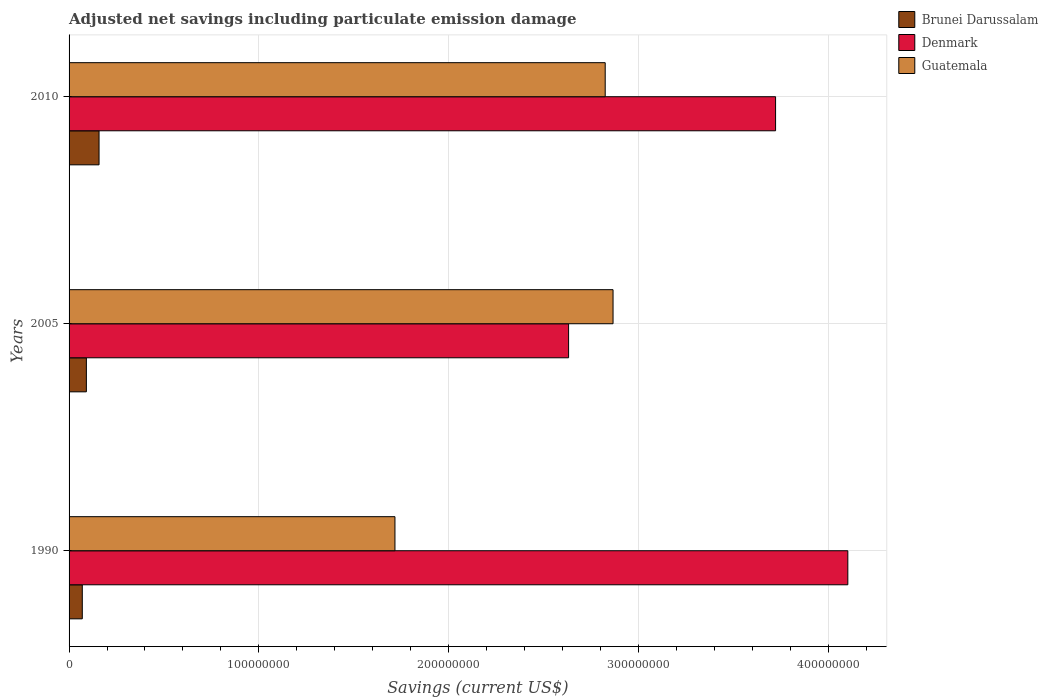How many different coloured bars are there?
Offer a very short reply. 3. How many groups of bars are there?
Keep it short and to the point. 3. How many bars are there on the 1st tick from the top?
Keep it short and to the point. 3. What is the net savings in Denmark in 2010?
Offer a terse response. 3.72e+08. Across all years, what is the maximum net savings in Guatemala?
Your answer should be compact. 2.87e+08. Across all years, what is the minimum net savings in Brunei Darussalam?
Ensure brevity in your answer.  6.97e+06. What is the total net savings in Brunei Darussalam in the graph?
Make the answer very short. 3.19e+07. What is the difference between the net savings in Guatemala in 2005 and that in 2010?
Your answer should be compact. 4.13e+06. What is the difference between the net savings in Guatemala in 2010 and the net savings in Brunei Darussalam in 2005?
Your answer should be compact. 2.73e+08. What is the average net savings in Denmark per year?
Give a very brief answer. 3.49e+08. In the year 2010, what is the difference between the net savings in Brunei Darussalam and net savings in Guatemala?
Your answer should be compact. -2.67e+08. What is the ratio of the net savings in Denmark in 1990 to that in 2010?
Keep it short and to the point. 1.1. What is the difference between the highest and the second highest net savings in Brunei Darussalam?
Your response must be concise. 6.68e+06. What is the difference between the highest and the lowest net savings in Guatemala?
Your answer should be compact. 1.15e+08. In how many years, is the net savings in Brunei Darussalam greater than the average net savings in Brunei Darussalam taken over all years?
Provide a succinct answer. 1. Is the sum of the net savings in Brunei Darussalam in 1990 and 2010 greater than the maximum net savings in Guatemala across all years?
Offer a terse response. No. What does the 3rd bar from the top in 2010 represents?
Give a very brief answer. Brunei Darussalam. What does the 3rd bar from the bottom in 2005 represents?
Ensure brevity in your answer.  Guatemala. Is it the case that in every year, the sum of the net savings in Denmark and net savings in Guatemala is greater than the net savings in Brunei Darussalam?
Offer a very short reply. Yes. How many bars are there?
Your response must be concise. 9. Are all the bars in the graph horizontal?
Your answer should be very brief. Yes. Does the graph contain any zero values?
Offer a terse response. No. Does the graph contain grids?
Your response must be concise. Yes. How are the legend labels stacked?
Provide a short and direct response. Vertical. What is the title of the graph?
Make the answer very short. Adjusted net savings including particulate emission damage. What is the label or title of the X-axis?
Provide a succinct answer. Savings (current US$). What is the label or title of the Y-axis?
Offer a very short reply. Years. What is the Savings (current US$) in Brunei Darussalam in 1990?
Give a very brief answer. 6.97e+06. What is the Savings (current US$) in Denmark in 1990?
Your response must be concise. 4.10e+08. What is the Savings (current US$) of Guatemala in 1990?
Your answer should be compact. 1.72e+08. What is the Savings (current US$) of Brunei Darussalam in 2005?
Make the answer very short. 9.12e+06. What is the Savings (current US$) of Denmark in 2005?
Provide a short and direct response. 2.63e+08. What is the Savings (current US$) of Guatemala in 2005?
Offer a very short reply. 2.87e+08. What is the Savings (current US$) in Brunei Darussalam in 2010?
Make the answer very short. 1.58e+07. What is the Savings (current US$) in Denmark in 2010?
Your response must be concise. 3.72e+08. What is the Savings (current US$) of Guatemala in 2010?
Your answer should be very brief. 2.83e+08. Across all years, what is the maximum Savings (current US$) in Brunei Darussalam?
Offer a terse response. 1.58e+07. Across all years, what is the maximum Savings (current US$) in Denmark?
Your response must be concise. 4.10e+08. Across all years, what is the maximum Savings (current US$) in Guatemala?
Keep it short and to the point. 2.87e+08. Across all years, what is the minimum Savings (current US$) in Brunei Darussalam?
Your response must be concise. 6.97e+06. Across all years, what is the minimum Savings (current US$) in Denmark?
Your answer should be compact. 2.63e+08. Across all years, what is the minimum Savings (current US$) in Guatemala?
Offer a terse response. 1.72e+08. What is the total Savings (current US$) of Brunei Darussalam in the graph?
Your response must be concise. 3.19e+07. What is the total Savings (current US$) of Denmark in the graph?
Provide a short and direct response. 1.05e+09. What is the total Savings (current US$) of Guatemala in the graph?
Make the answer very short. 7.41e+08. What is the difference between the Savings (current US$) of Brunei Darussalam in 1990 and that in 2005?
Ensure brevity in your answer.  -2.15e+06. What is the difference between the Savings (current US$) in Denmark in 1990 and that in 2005?
Offer a very short reply. 1.47e+08. What is the difference between the Savings (current US$) of Guatemala in 1990 and that in 2005?
Ensure brevity in your answer.  -1.15e+08. What is the difference between the Savings (current US$) of Brunei Darussalam in 1990 and that in 2010?
Ensure brevity in your answer.  -8.83e+06. What is the difference between the Savings (current US$) of Denmark in 1990 and that in 2010?
Provide a short and direct response. 3.81e+07. What is the difference between the Savings (current US$) in Guatemala in 1990 and that in 2010?
Provide a succinct answer. -1.11e+08. What is the difference between the Savings (current US$) in Brunei Darussalam in 2005 and that in 2010?
Offer a terse response. -6.68e+06. What is the difference between the Savings (current US$) in Denmark in 2005 and that in 2010?
Ensure brevity in your answer.  -1.09e+08. What is the difference between the Savings (current US$) of Guatemala in 2005 and that in 2010?
Keep it short and to the point. 4.13e+06. What is the difference between the Savings (current US$) in Brunei Darussalam in 1990 and the Savings (current US$) in Denmark in 2005?
Offer a terse response. -2.56e+08. What is the difference between the Savings (current US$) in Brunei Darussalam in 1990 and the Savings (current US$) in Guatemala in 2005?
Provide a short and direct response. -2.80e+08. What is the difference between the Savings (current US$) in Denmark in 1990 and the Savings (current US$) in Guatemala in 2005?
Offer a very short reply. 1.24e+08. What is the difference between the Savings (current US$) in Brunei Darussalam in 1990 and the Savings (current US$) in Denmark in 2010?
Offer a very short reply. -3.65e+08. What is the difference between the Savings (current US$) in Brunei Darussalam in 1990 and the Savings (current US$) in Guatemala in 2010?
Keep it short and to the point. -2.76e+08. What is the difference between the Savings (current US$) in Denmark in 1990 and the Savings (current US$) in Guatemala in 2010?
Offer a very short reply. 1.28e+08. What is the difference between the Savings (current US$) in Brunei Darussalam in 2005 and the Savings (current US$) in Denmark in 2010?
Give a very brief answer. -3.63e+08. What is the difference between the Savings (current US$) in Brunei Darussalam in 2005 and the Savings (current US$) in Guatemala in 2010?
Offer a very short reply. -2.73e+08. What is the difference between the Savings (current US$) in Denmark in 2005 and the Savings (current US$) in Guatemala in 2010?
Your answer should be compact. -1.93e+07. What is the average Savings (current US$) of Brunei Darussalam per year?
Give a very brief answer. 1.06e+07. What is the average Savings (current US$) in Denmark per year?
Ensure brevity in your answer.  3.49e+08. What is the average Savings (current US$) in Guatemala per year?
Offer a terse response. 2.47e+08. In the year 1990, what is the difference between the Savings (current US$) of Brunei Darussalam and Savings (current US$) of Denmark?
Offer a very short reply. -4.03e+08. In the year 1990, what is the difference between the Savings (current US$) in Brunei Darussalam and Savings (current US$) in Guatemala?
Offer a very short reply. -1.65e+08. In the year 1990, what is the difference between the Savings (current US$) in Denmark and Savings (current US$) in Guatemala?
Your answer should be very brief. 2.39e+08. In the year 2005, what is the difference between the Savings (current US$) of Brunei Darussalam and Savings (current US$) of Denmark?
Make the answer very short. -2.54e+08. In the year 2005, what is the difference between the Savings (current US$) in Brunei Darussalam and Savings (current US$) in Guatemala?
Your answer should be very brief. -2.78e+08. In the year 2005, what is the difference between the Savings (current US$) in Denmark and Savings (current US$) in Guatemala?
Your answer should be compact. -2.34e+07. In the year 2010, what is the difference between the Savings (current US$) of Brunei Darussalam and Savings (current US$) of Denmark?
Your answer should be compact. -3.56e+08. In the year 2010, what is the difference between the Savings (current US$) in Brunei Darussalam and Savings (current US$) in Guatemala?
Your answer should be very brief. -2.67e+08. In the year 2010, what is the difference between the Savings (current US$) in Denmark and Savings (current US$) in Guatemala?
Provide a short and direct response. 8.98e+07. What is the ratio of the Savings (current US$) in Brunei Darussalam in 1990 to that in 2005?
Your answer should be very brief. 0.76. What is the ratio of the Savings (current US$) in Denmark in 1990 to that in 2005?
Offer a very short reply. 1.56. What is the ratio of the Savings (current US$) in Guatemala in 1990 to that in 2005?
Provide a succinct answer. 0.6. What is the ratio of the Savings (current US$) in Brunei Darussalam in 1990 to that in 2010?
Your answer should be compact. 0.44. What is the ratio of the Savings (current US$) of Denmark in 1990 to that in 2010?
Offer a terse response. 1.1. What is the ratio of the Savings (current US$) of Guatemala in 1990 to that in 2010?
Provide a short and direct response. 0.61. What is the ratio of the Savings (current US$) of Brunei Darussalam in 2005 to that in 2010?
Offer a terse response. 0.58. What is the ratio of the Savings (current US$) in Denmark in 2005 to that in 2010?
Your answer should be very brief. 0.71. What is the ratio of the Savings (current US$) in Guatemala in 2005 to that in 2010?
Your answer should be very brief. 1.01. What is the difference between the highest and the second highest Savings (current US$) of Brunei Darussalam?
Make the answer very short. 6.68e+06. What is the difference between the highest and the second highest Savings (current US$) of Denmark?
Ensure brevity in your answer.  3.81e+07. What is the difference between the highest and the second highest Savings (current US$) of Guatemala?
Keep it short and to the point. 4.13e+06. What is the difference between the highest and the lowest Savings (current US$) in Brunei Darussalam?
Provide a succinct answer. 8.83e+06. What is the difference between the highest and the lowest Savings (current US$) in Denmark?
Make the answer very short. 1.47e+08. What is the difference between the highest and the lowest Savings (current US$) of Guatemala?
Make the answer very short. 1.15e+08. 